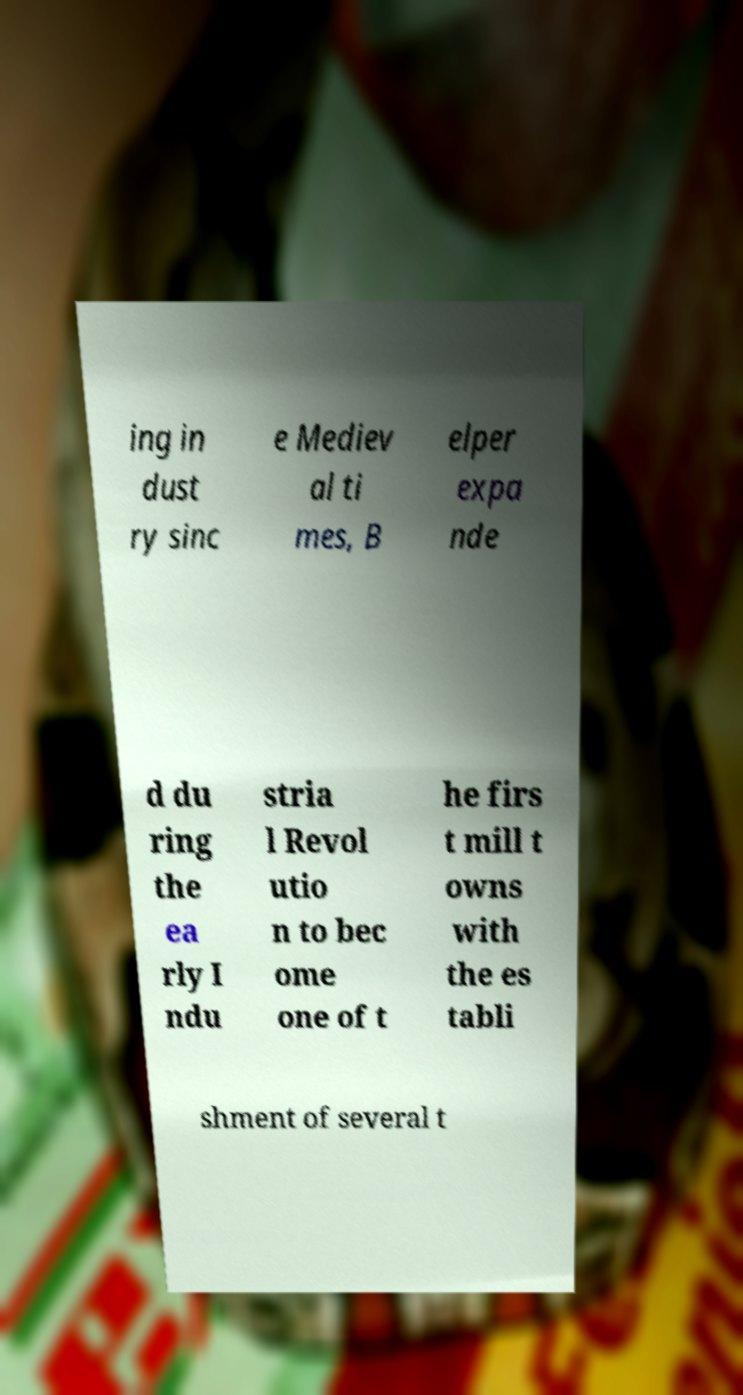What messages or text are displayed in this image? I need them in a readable, typed format. ing in dust ry sinc e Mediev al ti mes, B elper expa nde d du ring the ea rly I ndu stria l Revol utio n to bec ome one of t he firs t mill t owns with the es tabli shment of several t 